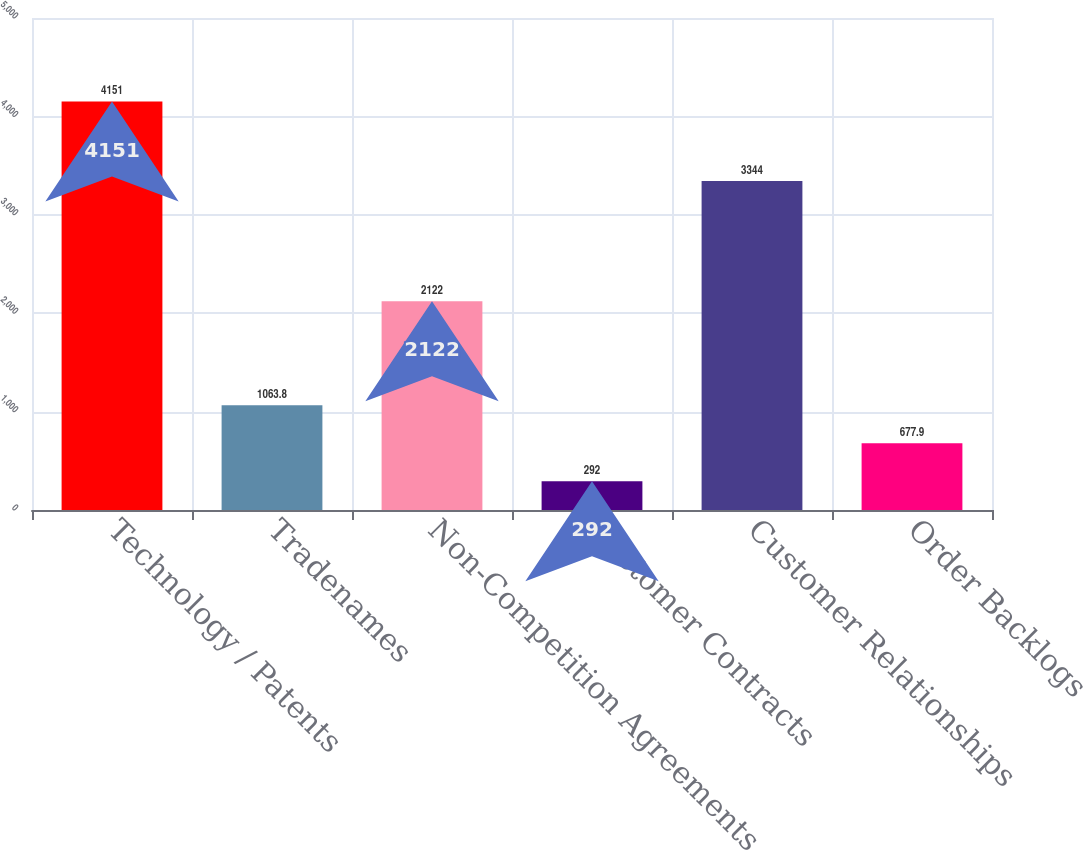Convert chart. <chart><loc_0><loc_0><loc_500><loc_500><bar_chart><fcel>Technology / Patents<fcel>Tradenames<fcel>Non-Competition Agreements<fcel>Customer Contracts<fcel>Customer Relationships<fcel>Order Backlogs<nl><fcel>4151<fcel>1063.8<fcel>2122<fcel>292<fcel>3344<fcel>677.9<nl></chart> 